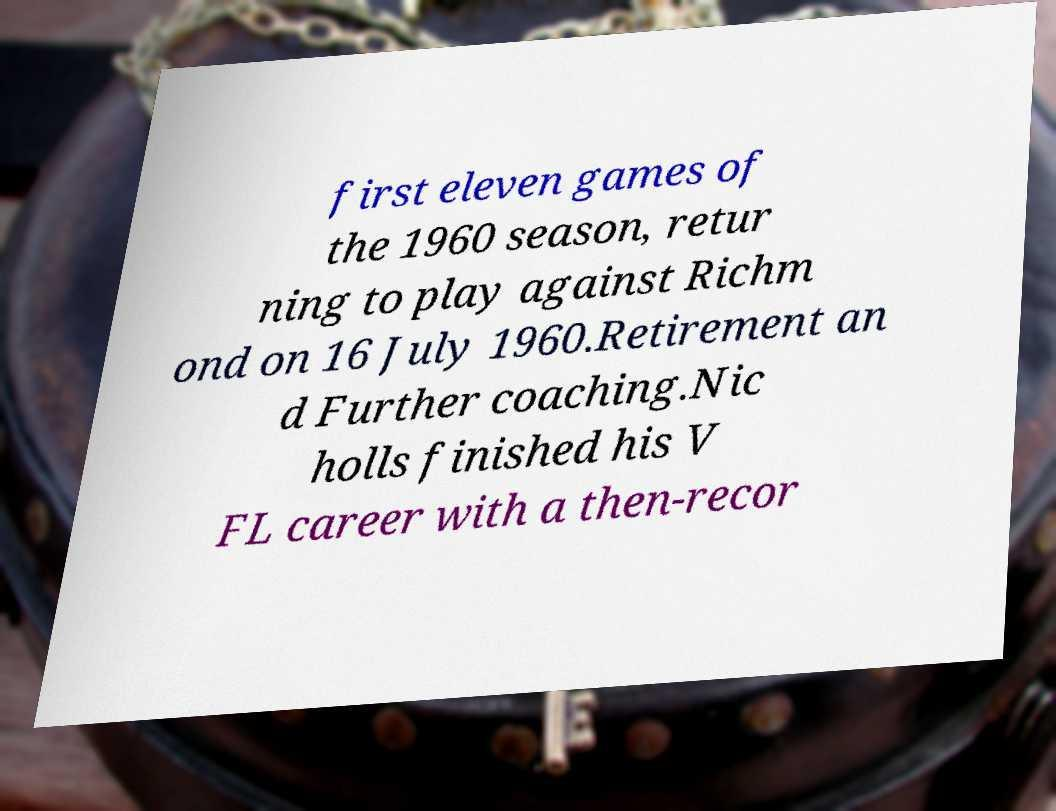There's text embedded in this image that I need extracted. Can you transcribe it verbatim? first eleven games of the 1960 season, retur ning to play against Richm ond on 16 July 1960.Retirement an d Further coaching.Nic holls finished his V FL career with a then-recor 